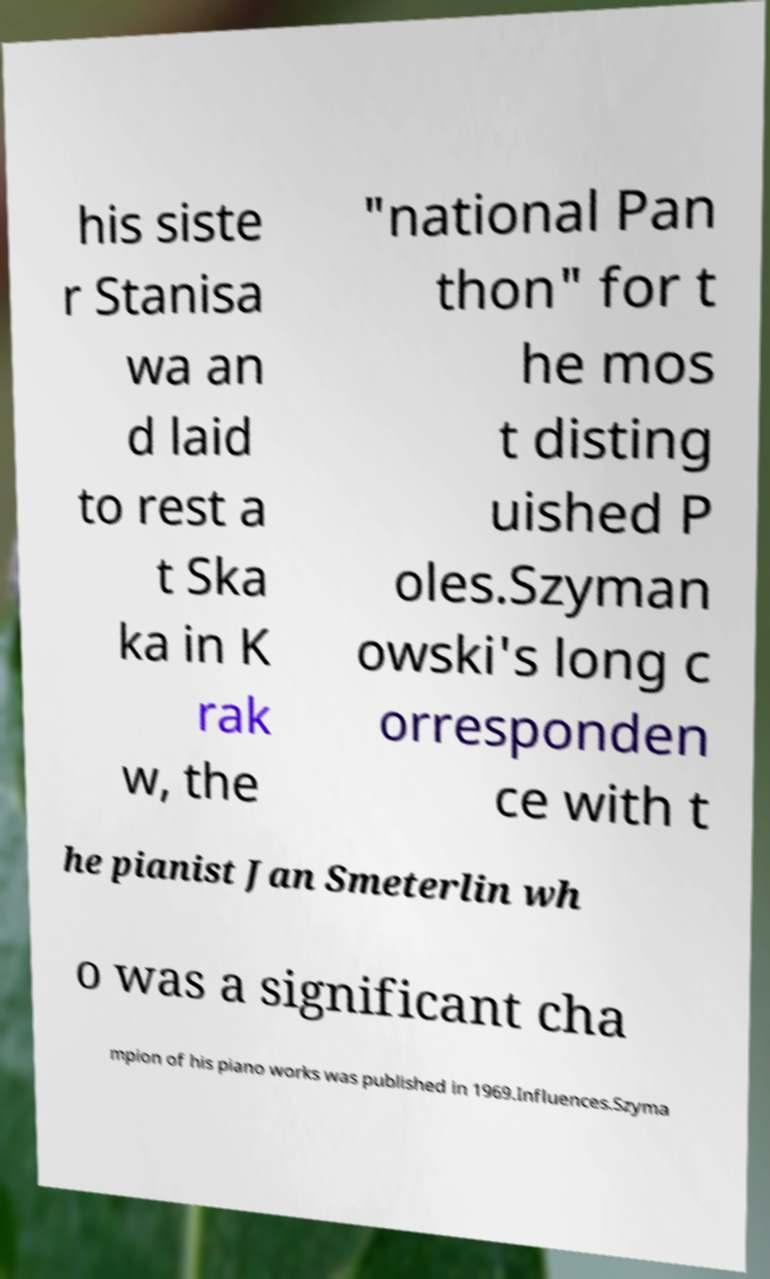Could you assist in decoding the text presented in this image and type it out clearly? his siste r Stanisa wa an d laid to rest a t Ska ka in K rak w, the "national Pan thon" for t he mos t disting uished P oles.Szyman owski's long c orresponden ce with t he pianist Jan Smeterlin wh o was a significant cha mpion of his piano works was published in 1969.Influences.Szyma 